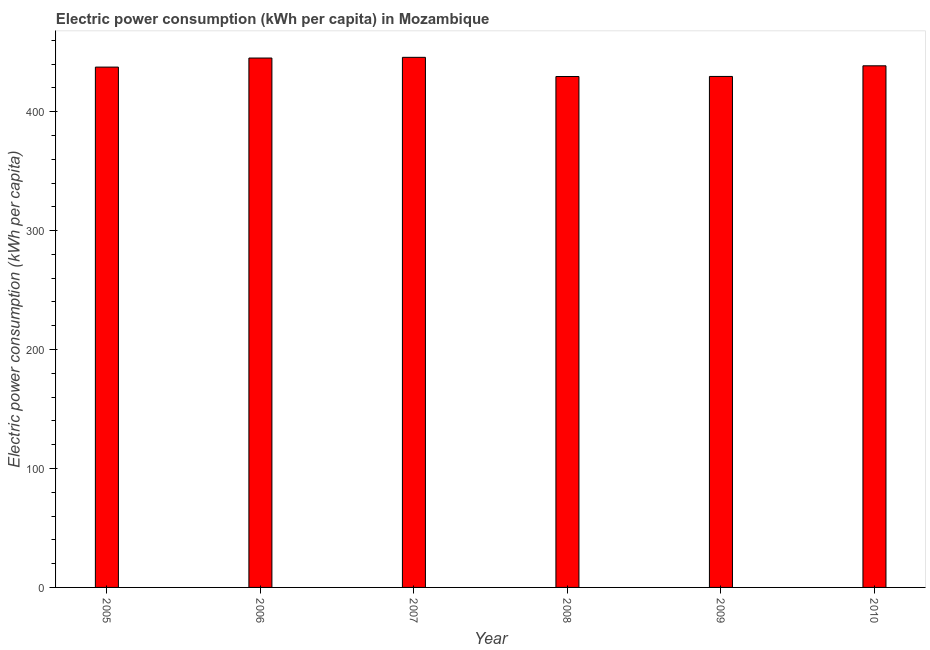What is the title of the graph?
Ensure brevity in your answer.  Electric power consumption (kWh per capita) in Mozambique. What is the label or title of the X-axis?
Your response must be concise. Year. What is the label or title of the Y-axis?
Make the answer very short. Electric power consumption (kWh per capita). What is the electric power consumption in 2005?
Your response must be concise. 437.5. Across all years, what is the maximum electric power consumption?
Your response must be concise. 445.71. Across all years, what is the minimum electric power consumption?
Offer a very short reply. 429.57. What is the sum of the electric power consumption?
Offer a terse response. 2626.14. What is the difference between the electric power consumption in 2006 and 2010?
Offer a very short reply. 6.54. What is the average electric power consumption per year?
Provide a short and direct response. 437.69. What is the median electric power consumption?
Offer a terse response. 438.04. What is the ratio of the electric power consumption in 2006 to that in 2008?
Your response must be concise. 1.04. Is the electric power consumption in 2008 less than that in 2010?
Your answer should be compact. Yes. What is the difference between the highest and the second highest electric power consumption?
Ensure brevity in your answer.  0.59. Is the sum of the electric power consumption in 2006 and 2010 greater than the maximum electric power consumption across all years?
Your answer should be very brief. Yes. What is the difference between the highest and the lowest electric power consumption?
Your answer should be compact. 16.14. How many bars are there?
Your answer should be compact. 6. What is the Electric power consumption (kWh per capita) in 2005?
Provide a succinct answer. 437.5. What is the Electric power consumption (kWh per capita) of 2006?
Provide a short and direct response. 445.12. What is the Electric power consumption (kWh per capita) in 2007?
Offer a terse response. 445.71. What is the Electric power consumption (kWh per capita) in 2008?
Keep it short and to the point. 429.57. What is the Electric power consumption (kWh per capita) of 2009?
Your answer should be very brief. 429.64. What is the Electric power consumption (kWh per capita) of 2010?
Provide a short and direct response. 438.58. What is the difference between the Electric power consumption (kWh per capita) in 2005 and 2006?
Your response must be concise. -7.62. What is the difference between the Electric power consumption (kWh per capita) in 2005 and 2007?
Your answer should be compact. -8.21. What is the difference between the Electric power consumption (kWh per capita) in 2005 and 2008?
Ensure brevity in your answer.  7.93. What is the difference between the Electric power consumption (kWh per capita) in 2005 and 2009?
Ensure brevity in your answer.  7.87. What is the difference between the Electric power consumption (kWh per capita) in 2005 and 2010?
Your answer should be very brief. -1.08. What is the difference between the Electric power consumption (kWh per capita) in 2006 and 2007?
Your answer should be very brief. -0.59. What is the difference between the Electric power consumption (kWh per capita) in 2006 and 2008?
Offer a very short reply. 15.55. What is the difference between the Electric power consumption (kWh per capita) in 2006 and 2009?
Keep it short and to the point. 15.48. What is the difference between the Electric power consumption (kWh per capita) in 2006 and 2010?
Your response must be concise. 6.54. What is the difference between the Electric power consumption (kWh per capita) in 2007 and 2008?
Give a very brief answer. 16.14. What is the difference between the Electric power consumption (kWh per capita) in 2007 and 2009?
Ensure brevity in your answer.  16.08. What is the difference between the Electric power consumption (kWh per capita) in 2007 and 2010?
Provide a succinct answer. 7.13. What is the difference between the Electric power consumption (kWh per capita) in 2008 and 2009?
Give a very brief answer. -0.06. What is the difference between the Electric power consumption (kWh per capita) in 2008 and 2010?
Give a very brief answer. -9.01. What is the difference between the Electric power consumption (kWh per capita) in 2009 and 2010?
Provide a succinct answer. -8.95. What is the ratio of the Electric power consumption (kWh per capita) in 2005 to that in 2006?
Your answer should be compact. 0.98. What is the ratio of the Electric power consumption (kWh per capita) in 2005 to that in 2008?
Your answer should be very brief. 1.02. What is the ratio of the Electric power consumption (kWh per capita) in 2005 to that in 2009?
Offer a very short reply. 1.02. What is the ratio of the Electric power consumption (kWh per capita) in 2006 to that in 2008?
Your answer should be compact. 1.04. What is the ratio of the Electric power consumption (kWh per capita) in 2006 to that in 2009?
Your answer should be very brief. 1.04. What is the ratio of the Electric power consumption (kWh per capita) in 2007 to that in 2008?
Keep it short and to the point. 1.04. What is the ratio of the Electric power consumption (kWh per capita) in 2007 to that in 2009?
Your answer should be very brief. 1.04. What is the ratio of the Electric power consumption (kWh per capita) in 2007 to that in 2010?
Your answer should be very brief. 1.02. What is the ratio of the Electric power consumption (kWh per capita) in 2008 to that in 2010?
Your answer should be compact. 0.98. What is the ratio of the Electric power consumption (kWh per capita) in 2009 to that in 2010?
Your answer should be compact. 0.98. 